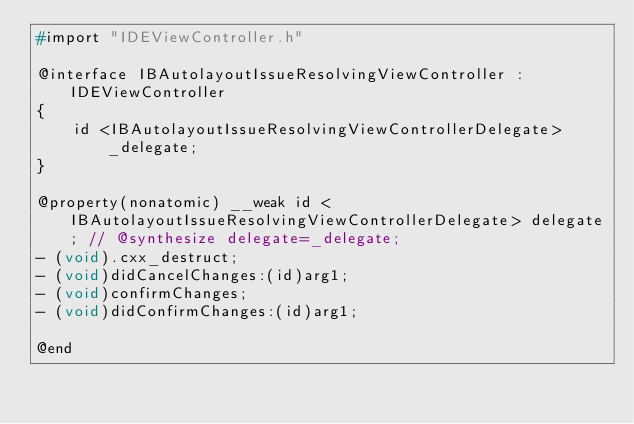Convert code to text. <code><loc_0><loc_0><loc_500><loc_500><_C_>#import "IDEViewController.h"

@interface IBAutolayoutIssueResolvingViewController : IDEViewController
{
    id <IBAutolayoutIssueResolvingViewControllerDelegate> _delegate;
}

@property(nonatomic) __weak id <IBAutolayoutIssueResolvingViewControllerDelegate> delegate; // @synthesize delegate=_delegate;
- (void).cxx_destruct;
- (void)didCancelChanges:(id)arg1;
- (void)confirmChanges;
- (void)didConfirmChanges:(id)arg1;

@end

</code> 